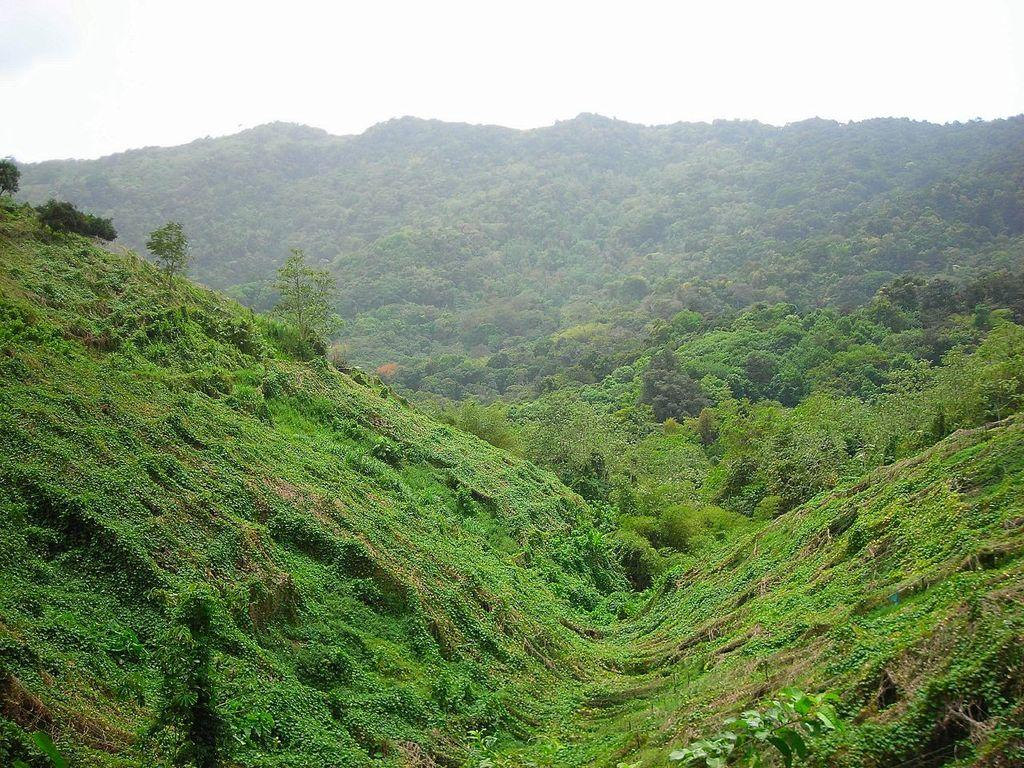What type of natural formation can be seen in the image? There are mountains in the image. What covers the mountains in the image? The mountains are covered with trees and plants. What part of the environment is visible in the image? The sky is visible in the image. What type of medical professional can be seen in the image? There are no medical professionals present in the image; it features mountains covered with trees and plants, with the sky visible. 